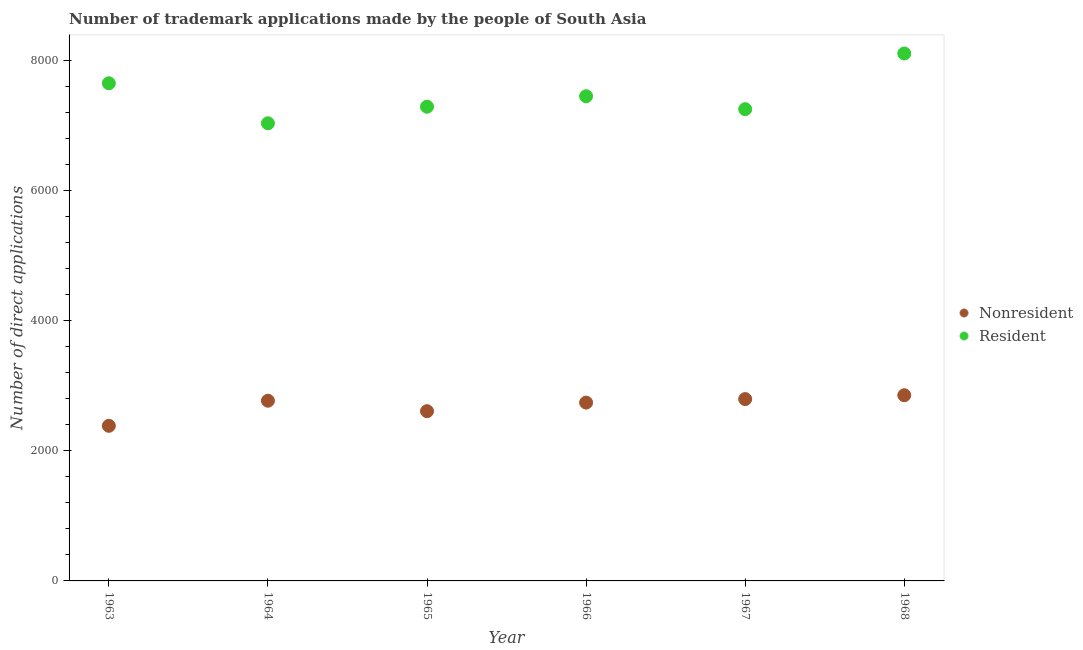Is the number of dotlines equal to the number of legend labels?
Provide a succinct answer. Yes. What is the number of trademark applications made by residents in 1963?
Keep it short and to the point. 7649. Across all years, what is the maximum number of trademark applications made by non residents?
Keep it short and to the point. 2854. Across all years, what is the minimum number of trademark applications made by residents?
Provide a short and direct response. 7034. In which year was the number of trademark applications made by non residents maximum?
Offer a terse response. 1968. In which year was the number of trademark applications made by residents minimum?
Your response must be concise. 1964. What is the total number of trademark applications made by non residents in the graph?
Provide a succinct answer. 1.62e+04. What is the difference between the number of trademark applications made by residents in 1966 and that in 1968?
Your response must be concise. -657. What is the difference between the number of trademark applications made by residents in 1966 and the number of trademark applications made by non residents in 1967?
Make the answer very short. 4655. What is the average number of trademark applications made by residents per year?
Provide a succinct answer. 7463.33. In the year 1963, what is the difference between the number of trademark applications made by non residents and number of trademark applications made by residents?
Keep it short and to the point. -5265. What is the ratio of the number of trademark applications made by non residents in 1966 to that in 1968?
Keep it short and to the point. 0.96. Is the number of trademark applications made by residents in 1966 less than that in 1968?
Your response must be concise. Yes. What is the difference between the highest and the second highest number of trademark applications made by residents?
Your answer should be compact. 458. What is the difference between the highest and the lowest number of trademark applications made by residents?
Give a very brief answer. 1073. In how many years, is the number of trademark applications made by residents greater than the average number of trademark applications made by residents taken over all years?
Ensure brevity in your answer.  2. Does the number of trademark applications made by non residents monotonically increase over the years?
Give a very brief answer. No. How many years are there in the graph?
Keep it short and to the point. 6. Does the graph contain any zero values?
Make the answer very short. No. Where does the legend appear in the graph?
Your answer should be very brief. Center right. What is the title of the graph?
Offer a terse response. Number of trademark applications made by the people of South Asia. What is the label or title of the Y-axis?
Keep it short and to the point. Number of direct applications. What is the Number of direct applications in Nonresident in 1963?
Keep it short and to the point. 2384. What is the Number of direct applications of Resident in 1963?
Give a very brief answer. 7649. What is the Number of direct applications of Nonresident in 1964?
Your answer should be very brief. 2770. What is the Number of direct applications of Resident in 1964?
Your answer should be very brief. 7034. What is the Number of direct applications in Nonresident in 1965?
Your response must be concise. 2609. What is the Number of direct applications in Resident in 1965?
Make the answer very short. 7289. What is the Number of direct applications in Nonresident in 1966?
Your answer should be compact. 2741. What is the Number of direct applications of Resident in 1966?
Make the answer very short. 7450. What is the Number of direct applications of Nonresident in 1967?
Provide a short and direct response. 2795. What is the Number of direct applications of Resident in 1967?
Your response must be concise. 7251. What is the Number of direct applications of Nonresident in 1968?
Your answer should be compact. 2854. What is the Number of direct applications of Resident in 1968?
Ensure brevity in your answer.  8107. Across all years, what is the maximum Number of direct applications of Nonresident?
Provide a short and direct response. 2854. Across all years, what is the maximum Number of direct applications in Resident?
Offer a very short reply. 8107. Across all years, what is the minimum Number of direct applications in Nonresident?
Offer a very short reply. 2384. Across all years, what is the minimum Number of direct applications in Resident?
Provide a succinct answer. 7034. What is the total Number of direct applications in Nonresident in the graph?
Make the answer very short. 1.62e+04. What is the total Number of direct applications in Resident in the graph?
Your answer should be very brief. 4.48e+04. What is the difference between the Number of direct applications in Nonresident in 1963 and that in 1964?
Give a very brief answer. -386. What is the difference between the Number of direct applications of Resident in 1963 and that in 1964?
Offer a terse response. 615. What is the difference between the Number of direct applications in Nonresident in 1963 and that in 1965?
Give a very brief answer. -225. What is the difference between the Number of direct applications of Resident in 1963 and that in 1965?
Make the answer very short. 360. What is the difference between the Number of direct applications of Nonresident in 1963 and that in 1966?
Offer a terse response. -357. What is the difference between the Number of direct applications of Resident in 1963 and that in 1966?
Offer a terse response. 199. What is the difference between the Number of direct applications in Nonresident in 1963 and that in 1967?
Make the answer very short. -411. What is the difference between the Number of direct applications in Resident in 1963 and that in 1967?
Provide a succinct answer. 398. What is the difference between the Number of direct applications of Nonresident in 1963 and that in 1968?
Give a very brief answer. -470. What is the difference between the Number of direct applications of Resident in 1963 and that in 1968?
Your response must be concise. -458. What is the difference between the Number of direct applications of Nonresident in 1964 and that in 1965?
Your answer should be compact. 161. What is the difference between the Number of direct applications of Resident in 1964 and that in 1965?
Provide a succinct answer. -255. What is the difference between the Number of direct applications of Nonresident in 1964 and that in 1966?
Ensure brevity in your answer.  29. What is the difference between the Number of direct applications of Resident in 1964 and that in 1966?
Keep it short and to the point. -416. What is the difference between the Number of direct applications of Resident in 1964 and that in 1967?
Provide a succinct answer. -217. What is the difference between the Number of direct applications in Nonresident in 1964 and that in 1968?
Ensure brevity in your answer.  -84. What is the difference between the Number of direct applications of Resident in 1964 and that in 1968?
Ensure brevity in your answer.  -1073. What is the difference between the Number of direct applications of Nonresident in 1965 and that in 1966?
Offer a terse response. -132. What is the difference between the Number of direct applications in Resident in 1965 and that in 1966?
Your answer should be very brief. -161. What is the difference between the Number of direct applications in Nonresident in 1965 and that in 1967?
Keep it short and to the point. -186. What is the difference between the Number of direct applications of Resident in 1965 and that in 1967?
Keep it short and to the point. 38. What is the difference between the Number of direct applications of Nonresident in 1965 and that in 1968?
Provide a short and direct response. -245. What is the difference between the Number of direct applications in Resident in 1965 and that in 1968?
Your answer should be very brief. -818. What is the difference between the Number of direct applications of Nonresident in 1966 and that in 1967?
Your answer should be compact. -54. What is the difference between the Number of direct applications of Resident in 1966 and that in 1967?
Give a very brief answer. 199. What is the difference between the Number of direct applications in Nonresident in 1966 and that in 1968?
Provide a succinct answer. -113. What is the difference between the Number of direct applications in Resident in 1966 and that in 1968?
Offer a very short reply. -657. What is the difference between the Number of direct applications in Nonresident in 1967 and that in 1968?
Give a very brief answer. -59. What is the difference between the Number of direct applications of Resident in 1967 and that in 1968?
Ensure brevity in your answer.  -856. What is the difference between the Number of direct applications of Nonresident in 1963 and the Number of direct applications of Resident in 1964?
Keep it short and to the point. -4650. What is the difference between the Number of direct applications of Nonresident in 1963 and the Number of direct applications of Resident in 1965?
Your answer should be very brief. -4905. What is the difference between the Number of direct applications of Nonresident in 1963 and the Number of direct applications of Resident in 1966?
Offer a very short reply. -5066. What is the difference between the Number of direct applications in Nonresident in 1963 and the Number of direct applications in Resident in 1967?
Give a very brief answer. -4867. What is the difference between the Number of direct applications in Nonresident in 1963 and the Number of direct applications in Resident in 1968?
Your answer should be compact. -5723. What is the difference between the Number of direct applications of Nonresident in 1964 and the Number of direct applications of Resident in 1965?
Offer a very short reply. -4519. What is the difference between the Number of direct applications in Nonresident in 1964 and the Number of direct applications in Resident in 1966?
Keep it short and to the point. -4680. What is the difference between the Number of direct applications of Nonresident in 1964 and the Number of direct applications of Resident in 1967?
Give a very brief answer. -4481. What is the difference between the Number of direct applications of Nonresident in 1964 and the Number of direct applications of Resident in 1968?
Make the answer very short. -5337. What is the difference between the Number of direct applications in Nonresident in 1965 and the Number of direct applications in Resident in 1966?
Your answer should be very brief. -4841. What is the difference between the Number of direct applications of Nonresident in 1965 and the Number of direct applications of Resident in 1967?
Your answer should be very brief. -4642. What is the difference between the Number of direct applications of Nonresident in 1965 and the Number of direct applications of Resident in 1968?
Your answer should be very brief. -5498. What is the difference between the Number of direct applications of Nonresident in 1966 and the Number of direct applications of Resident in 1967?
Your answer should be compact. -4510. What is the difference between the Number of direct applications in Nonresident in 1966 and the Number of direct applications in Resident in 1968?
Provide a succinct answer. -5366. What is the difference between the Number of direct applications in Nonresident in 1967 and the Number of direct applications in Resident in 1968?
Provide a short and direct response. -5312. What is the average Number of direct applications in Nonresident per year?
Ensure brevity in your answer.  2692.17. What is the average Number of direct applications in Resident per year?
Offer a terse response. 7463.33. In the year 1963, what is the difference between the Number of direct applications in Nonresident and Number of direct applications in Resident?
Give a very brief answer. -5265. In the year 1964, what is the difference between the Number of direct applications of Nonresident and Number of direct applications of Resident?
Your answer should be very brief. -4264. In the year 1965, what is the difference between the Number of direct applications of Nonresident and Number of direct applications of Resident?
Keep it short and to the point. -4680. In the year 1966, what is the difference between the Number of direct applications of Nonresident and Number of direct applications of Resident?
Ensure brevity in your answer.  -4709. In the year 1967, what is the difference between the Number of direct applications of Nonresident and Number of direct applications of Resident?
Offer a terse response. -4456. In the year 1968, what is the difference between the Number of direct applications of Nonresident and Number of direct applications of Resident?
Provide a short and direct response. -5253. What is the ratio of the Number of direct applications in Nonresident in 1963 to that in 1964?
Give a very brief answer. 0.86. What is the ratio of the Number of direct applications in Resident in 1963 to that in 1964?
Make the answer very short. 1.09. What is the ratio of the Number of direct applications of Nonresident in 1963 to that in 1965?
Provide a short and direct response. 0.91. What is the ratio of the Number of direct applications in Resident in 1963 to that in 1965?
Your answer should be very brief. 1.05. What is the ratio of the Number of direct applications of Nonresident in 1963 to that in 1966?
Provide a short and direct response. 0.87. What is the ratio of the Number of direct applications of Resident in 1963 to that in 1966?
Make the answer very short. 1.03. What is the ratio of the Number of direct applications of Nonresident in 1963 to that in 1967?
Give a very brief answer. 0.85. What is the ratio of the Number of direct applications of Resident in 1963 to that in 1967?
Your answer should be compact. 1.05. What is the ratio of the Number of direct applications of Nonresident in 1963 to that in 1968?
Give a very brief answer. 0.84. What is the ratio of the Number of direct applications of Resident in 1963 to that in 1968?
Offer a very short reply. 0.94. What is the ratio of the Number of direct applications in Nonresident in 1964 to that in 1965?
Ensure brevity in your answer.  1.06. What is the ratio of the Number of direct applications of Resident in 1964 to that in 1965?
Your response must be concise. 0.96. What is the ratio of the Number of direct applications of Nonresident in 1964 to that in 1966?
Make the answer very short. 1.01. What is the ratio of the Number of direct applications in Resident in 1964 to that in 1966?
Ensure brevity in your answer.  0.94. What is the ratio of the Number of direct applications in Resident in 1964 to that in 1967?
Provide a succinct answer. 0.97. What is the ratio of the Number of direct applications of Nonresident in 1964 to that in 1968?
Keep it short and to the point. 0.97. What is the ratio of the Number of direct applications of Resident in 1964 to that in 1968?
Your answer should be compact. 0.87. What is the ratio of the Number of direct applications in Nonresident in 1965 to that in 1966?
Ensure brevity in your answer.  0.95. What is the ratio of the Number of direct applications in Resident in 1965 to that in 1966?
Your answer should be compact. 0.98. What is the ratio of the Number of direct applications in Nonresident in 1965 to that in 1967?
Your answer should be very brief. 0.93. What is the ratio of the Number of direct applications of Nonresident in 1965 to that in 1968?
Provide a succinct answer. 0.91. What is the ratio of the Number of direct applications in Resident in 1965 to that in 1968?
Your answer should be compact. 0.9. What is the ratio of the Number of direct applications in Nonresident in 1966 to that in 1967?
Ensure brevity in your answer.  0.98. What is the ratio of the Number of direct applications of Resident in 1966 to that in 1967?
Your response must be concise. 1.03. What is the ratio of the Number of direct applications in Nonresident in 1966 to that in 1968?
Offer a terse response. 0.96. What is the ratio of the Number of direct applications of Resident in 1966 to that in 1968?
Ensure brevity in your answer.  0.92. What is the ratio of the Number of direct applications in Nonresident in 1967 to that in 1968?
Ensure brevity in your answer.  0.98. What is the ratio of the Number of direct applications in Resident in 1967 to that in 1968?
Keep it short and to the point. 0.89. What is the difference between the highest and the second highest Number of direct applications in Resident?
Keep it short and to the point. 458. What is the difference between the highest and the lowest Number of direct applications in Nonresident?
Ensure brevity in your answer.  470. What is the difference between the highest and the lowest Number of direct applications in Resident?
Keep it short and to the point. 1073. 